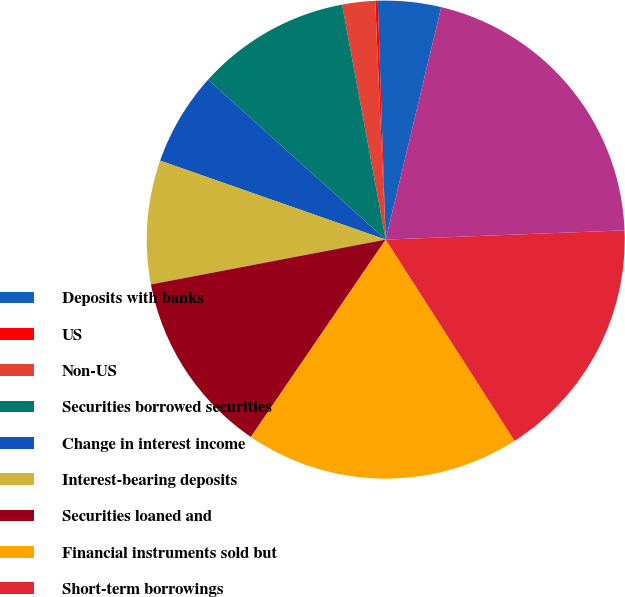<chart> <loc_0><loc_0><loc_500><loc_500><pie_chart><fcel>Deposits with banks<fcel>US<fcel>Non-US<fcel>Securities borrowed securities<fcel>Change in interest income<fcel>Interest-bearing deposits<fcel>Securities loaned and<fcel>Financial instruments sold but<fcel>Short-term borrowings<fcel>Long-term borrowings<nl><fcel>4.26%<fcel>0.17%<fcel>2.22%<fcel>10.41%<fcel>6.31%<fcel>8.36%<fcel>12.46%<fcel>18.6%<fcel>16.55%<fcel>20.65%<nl></chart> 